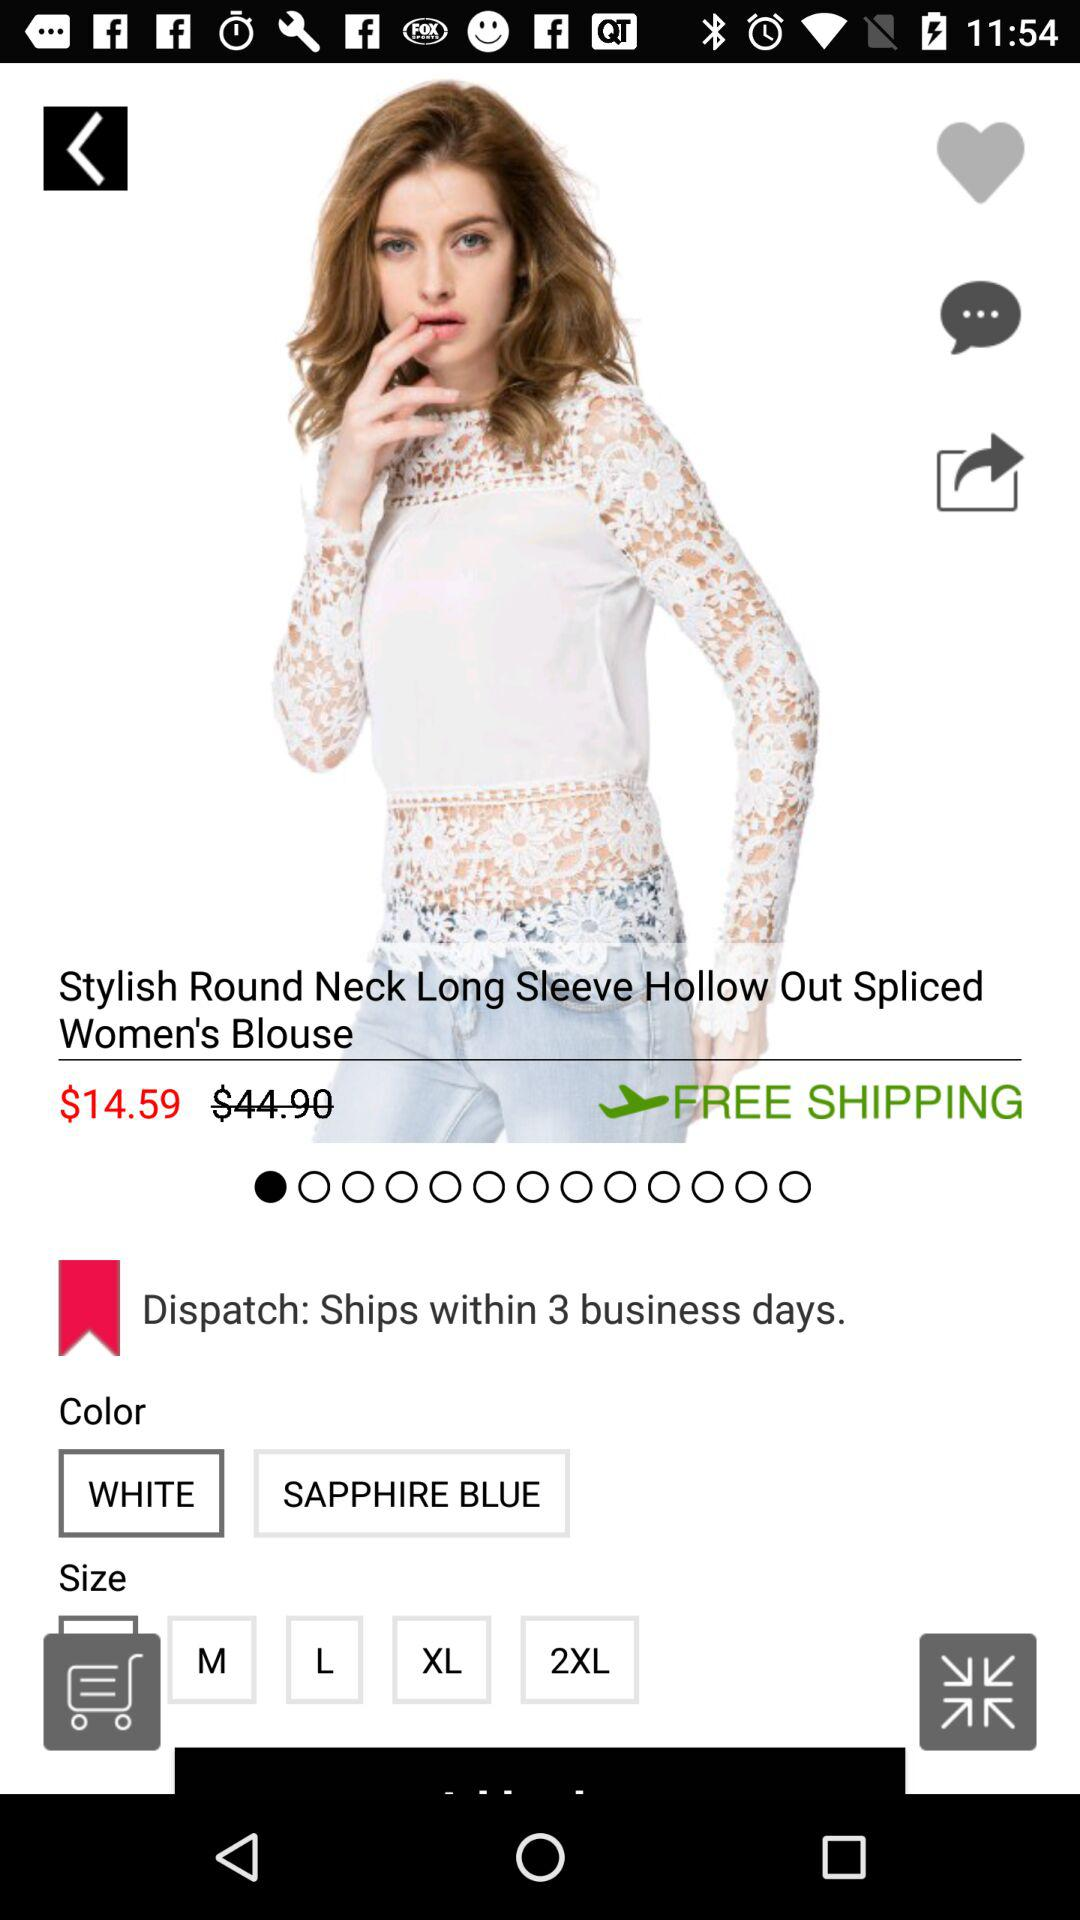How many different color options are there for this item?
Answer the question using a single word or phrase. 2 